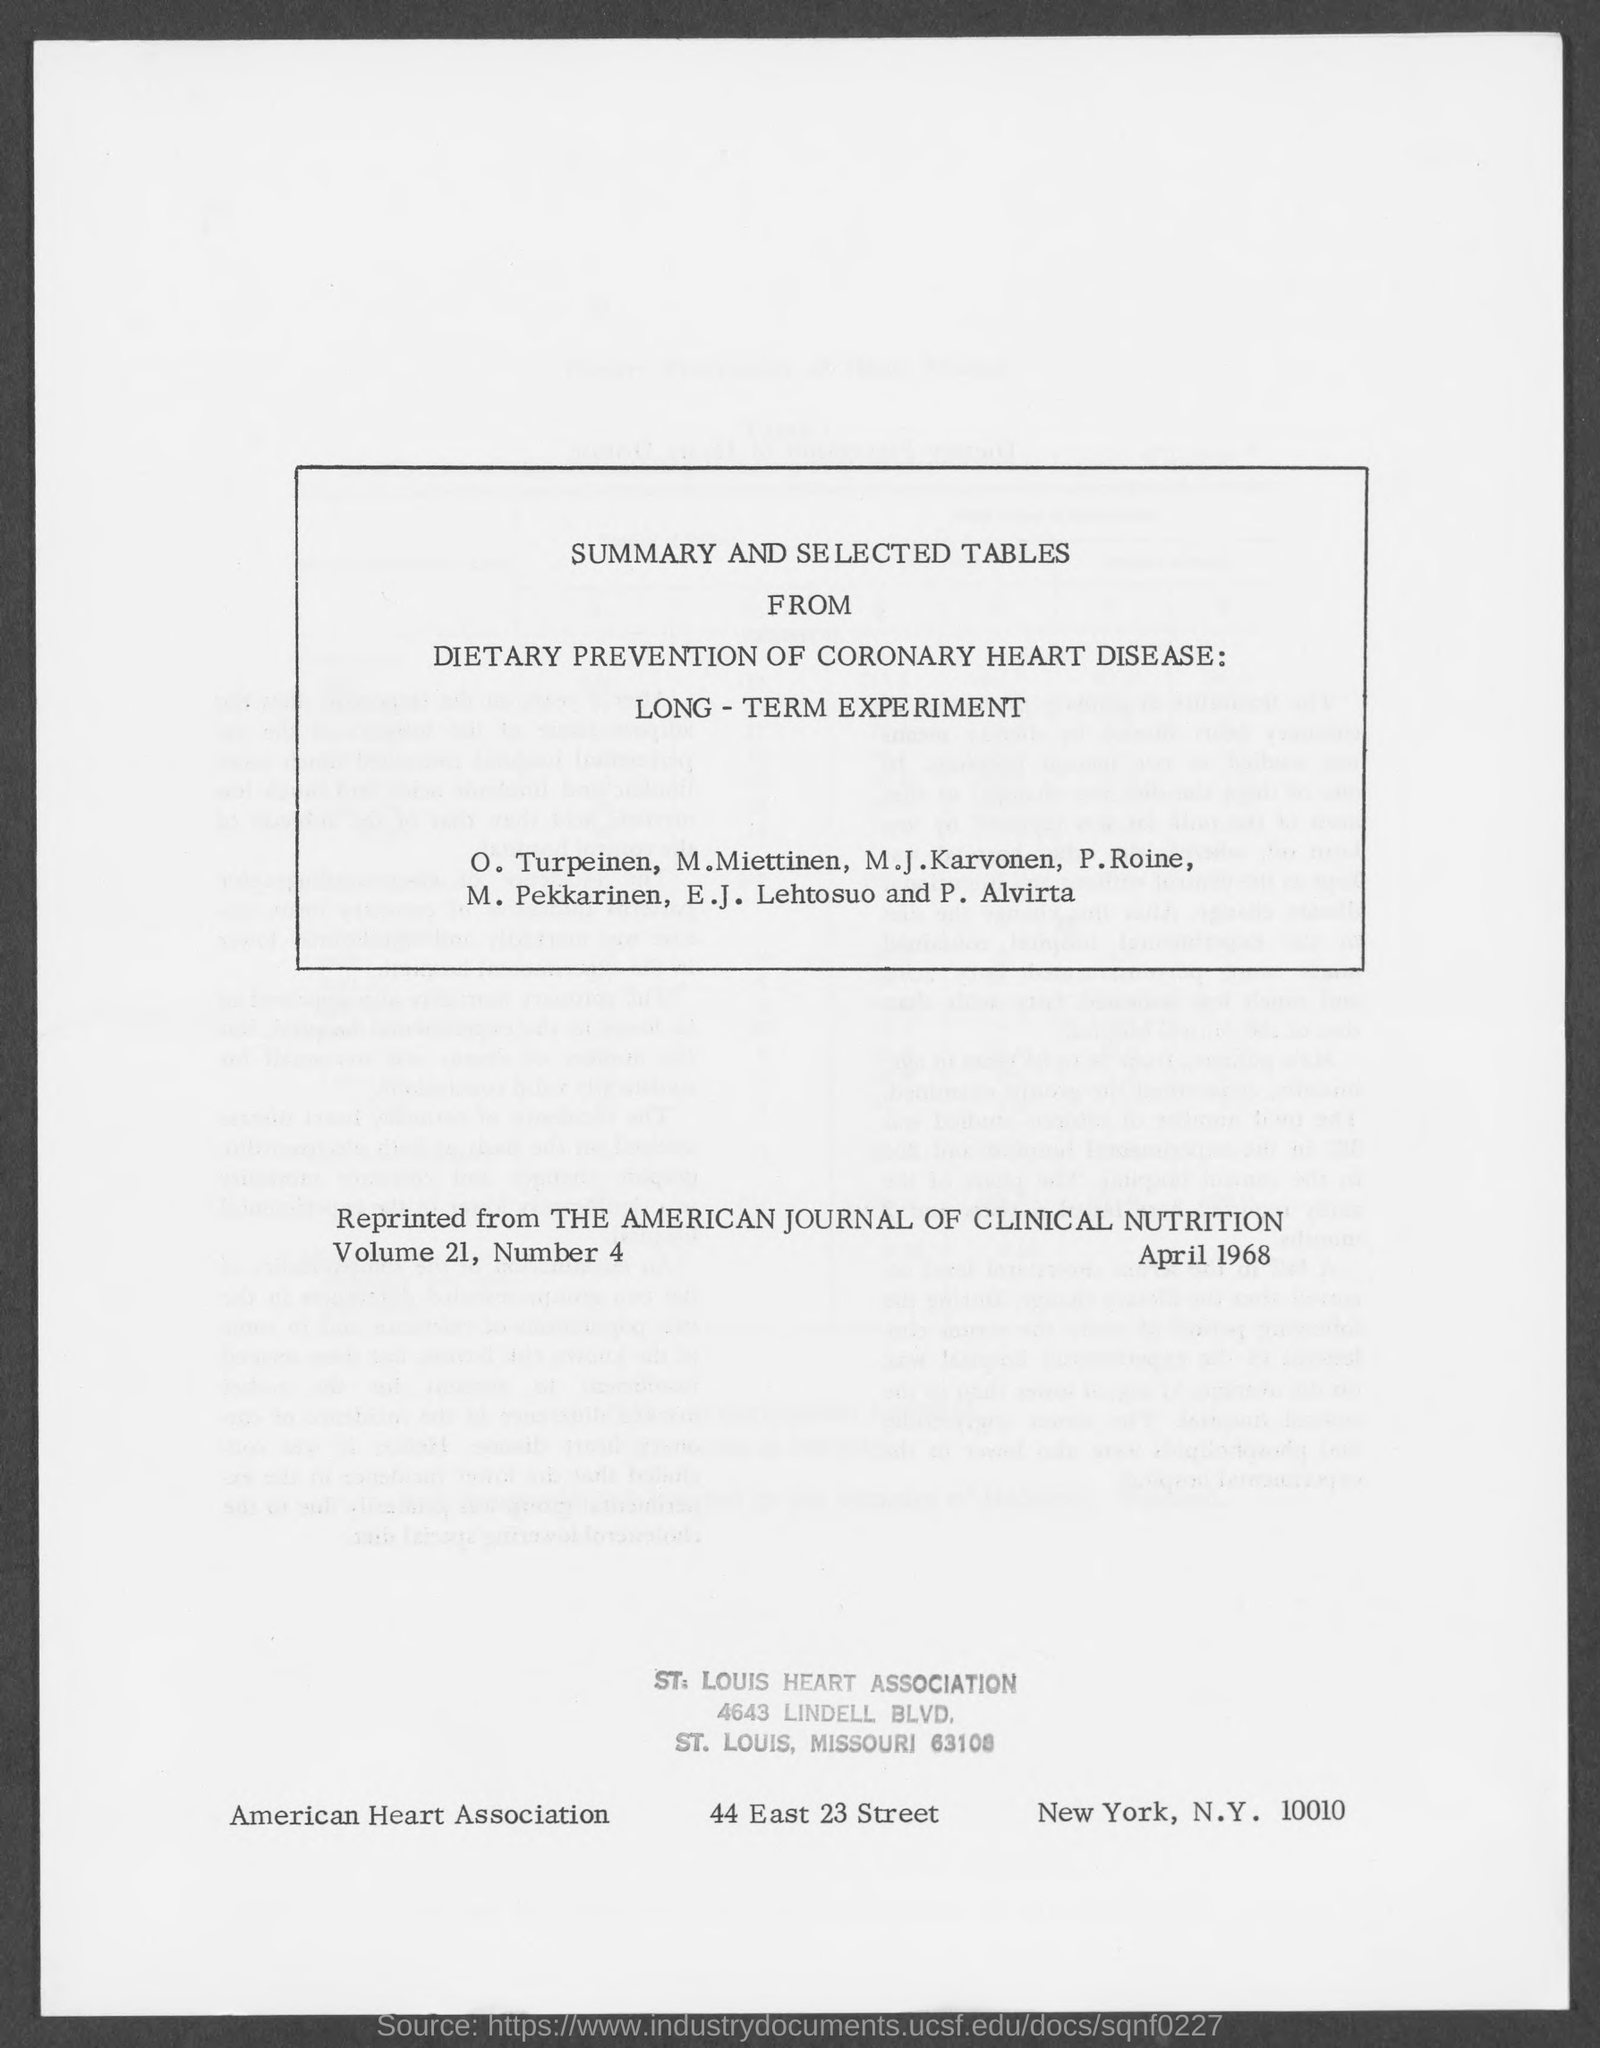What is the street address of st. louis heart association ?
Keep it short and to the point. 4643 Lindell Blvd. What is the street address of american heart association ?
Provide a succinct answer. 44 east 23 street. 